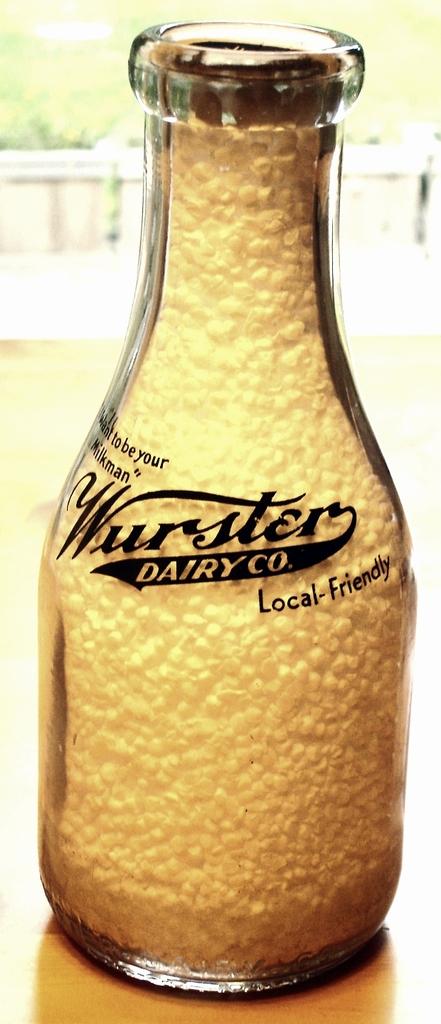What kind of company is wurster?
Make the answer very short. Dairy. What type of friendly?
Your answer should be compact. Local. 